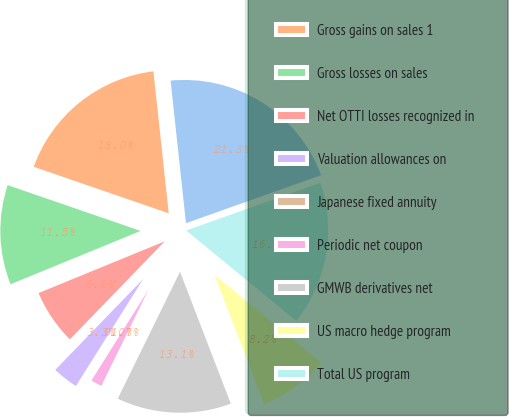Convert chart. <chart><loc_0><loc_0><loc_500><loc_500><pie_chart><fcel>(Before-tax)<fcel>Gross gains on sales 1<fcel>Gross losses on sales<fcel>Net OTTI losses recognized in<fcel>Valuation allowances on<fcel>Japanese fixed annuity<fcel>Periodic net coupon<fcel>GMWB derivatives net<fcel>US macro hedge program<fcel>Total US program<nl><fcel>21.28%<fcel>18.01%<fcel>11.47%<fcel>6.57%<fcel>3.3%<fcel>0.02%<fcel>1.66%<fcel>13.11%<fcel>8.2%<fcel>16.38%<nl></chart> 